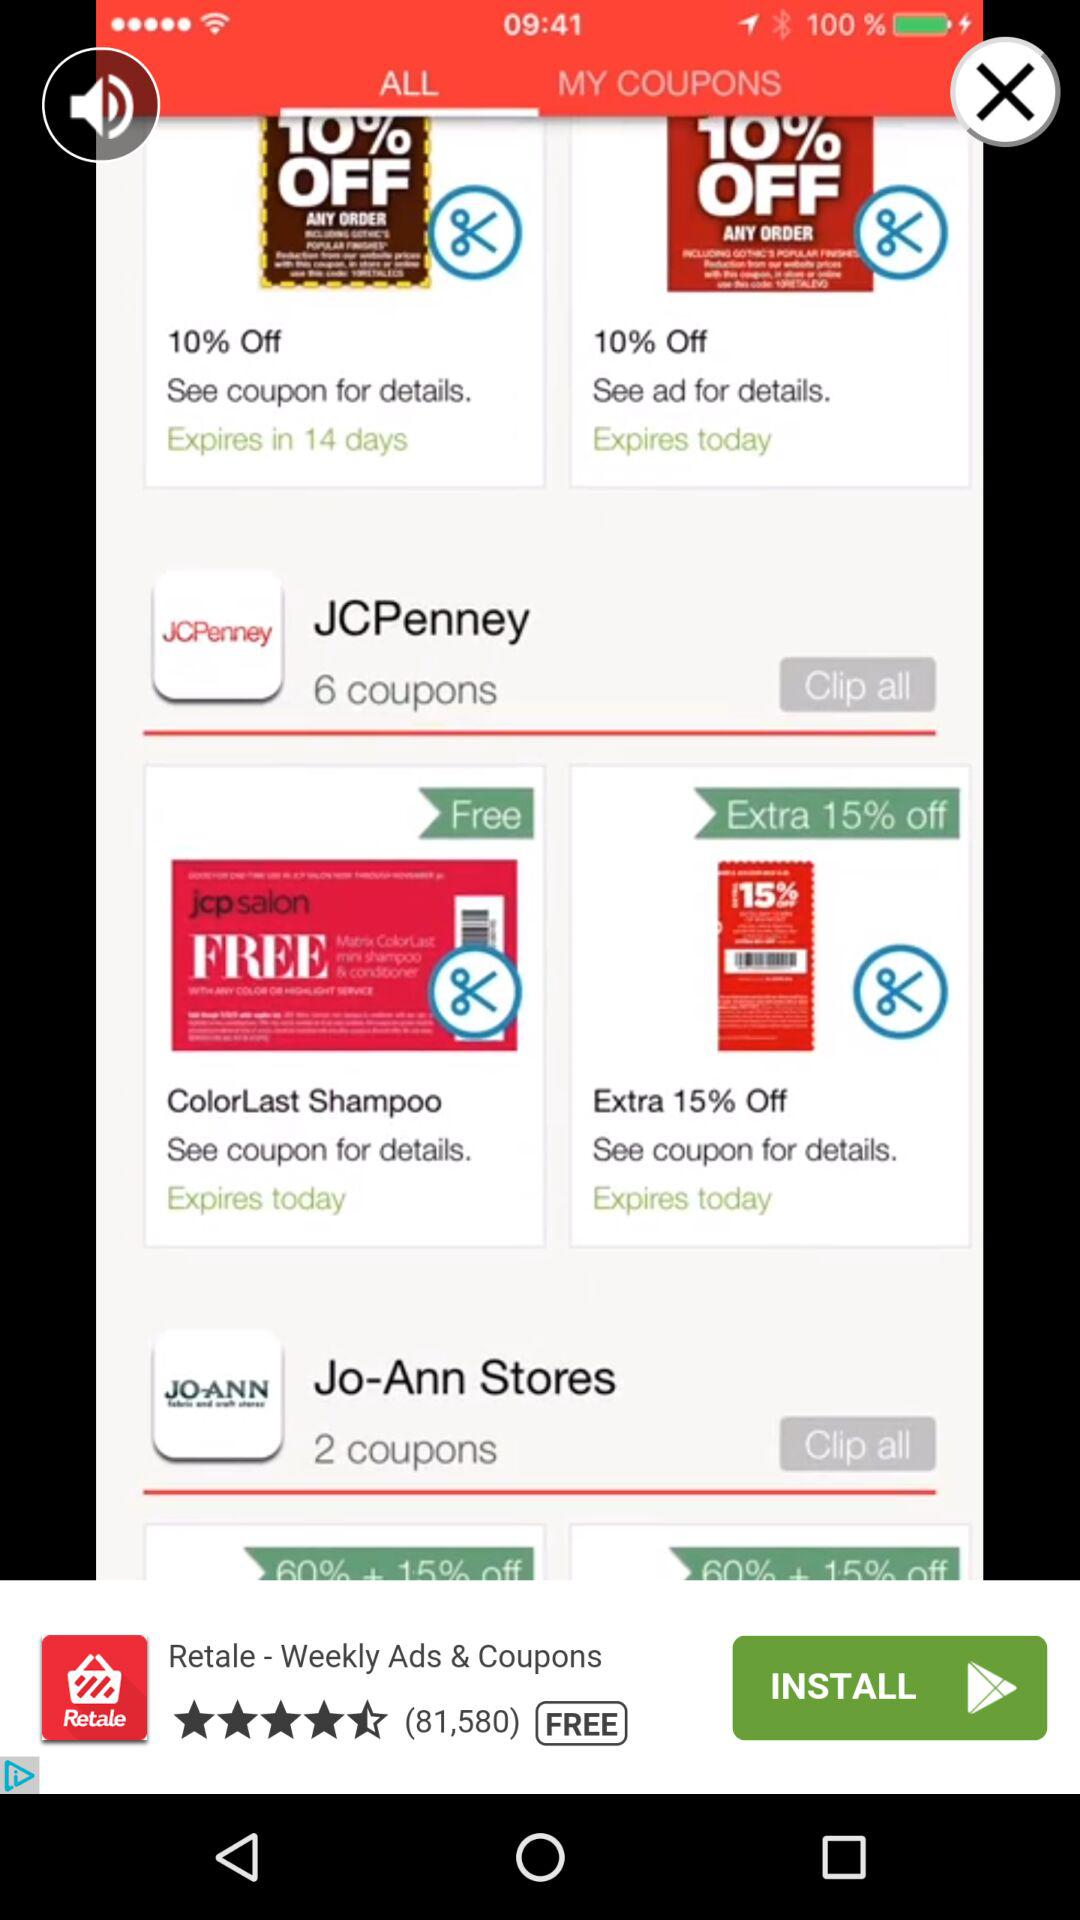When do the coupons for Jo-Ann Stores expire?
When the provided information is insufficient, respond with <no answer>. <no answer> 